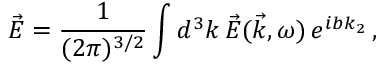Convert formula to latex. <formula><loc_0><loc_0><loc_500><loc_500>\vec { E } = \frac { 1 } { ( 2 \pi ) ^ { 3 / 2 } } \int d ^ { 3 } k \, \vec { E } ( \vec { k } , \omega ) \, e ^ { i b k _ { 2 } } \, ,</formula> 